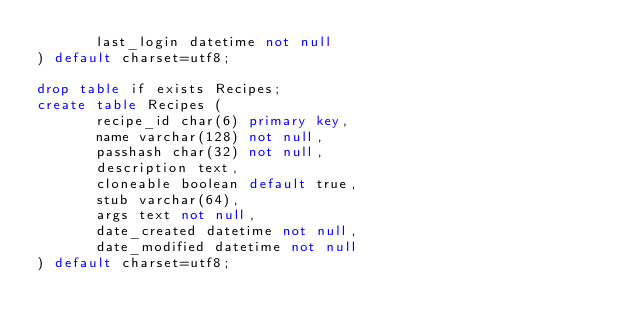<code> <loc_0><loc_0><loc_500><loc_500><_SQL_>       last_login datetime not null
) default charset=utf8;

drop table if exists Recipes;
create table Recipes (
       recipe_id char(6) primary key,
       name varchar(128) not null,
       passhash char(32) not null,
       description text,
       cloneable boolean default true,
       stub varchar(64),
       args text not null,
       date_created datetime not null,
       date_modified datetime not null
) default charset=utf8;
</code> 